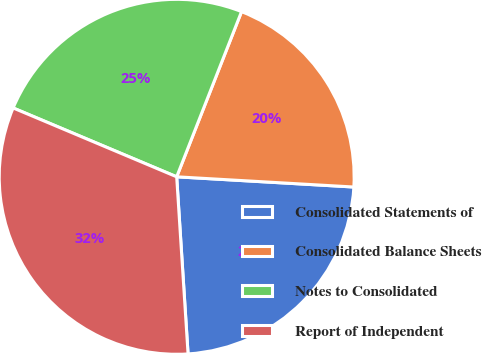Convert chart to OTSL. <chart><loc_0><loc_0><loc_500><loc_500><pie_chart><fcel>Consolidated Statements of<fcel>Consolidated Balance Sheets<fcel>Notes to Consolidated<fcel>Report of Independent<nl><fcel>23.06%<fcel>19.96%<fcel>24.61%<fcel>32.36%<nl></chart> 